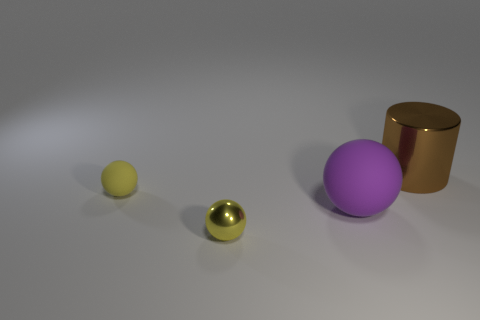How many yellow balls must be subtracted to get 1 yellow balls? 1 Add 3 small yellow rubber balls. How many objects exist? 7 Subtract all cylinders. How many objects are left? 3 Add 1 small yellow metallic balls. How many small yellow metallic balls are left? 2 Add 3 small yellow objects. How many small yellow objects exist? 5 Subtract 0 blue balls. How many objects are left? 4 Subtract all purple objects. Subtract all big matte balls. How many objects are left? 2 